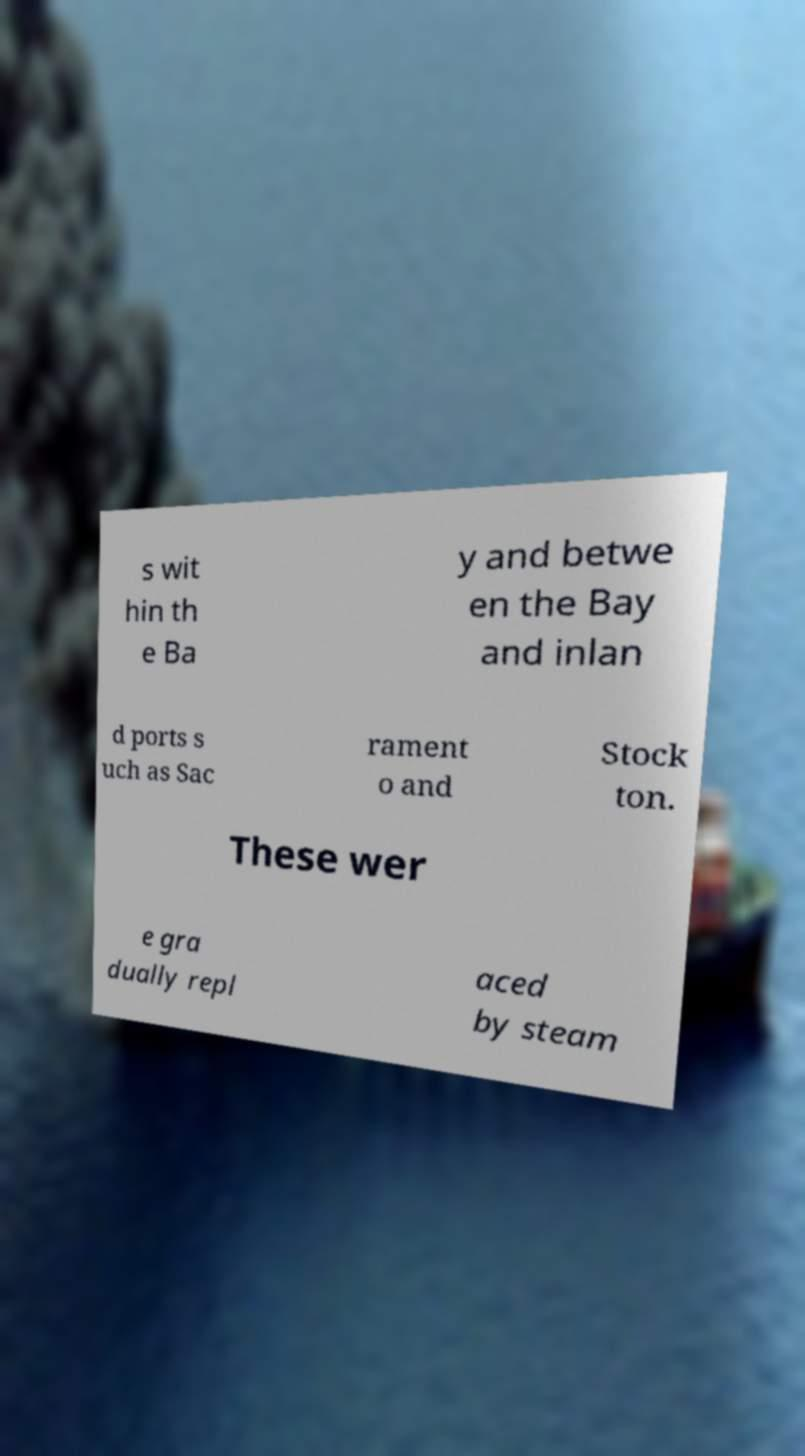Could you extract and type out the text from this image? s wit hin th e Ba y and betwe en the Bay and inlan d ports s uch as Sac rament o and Stock ton. These wer e gra dually repl aced by steam 